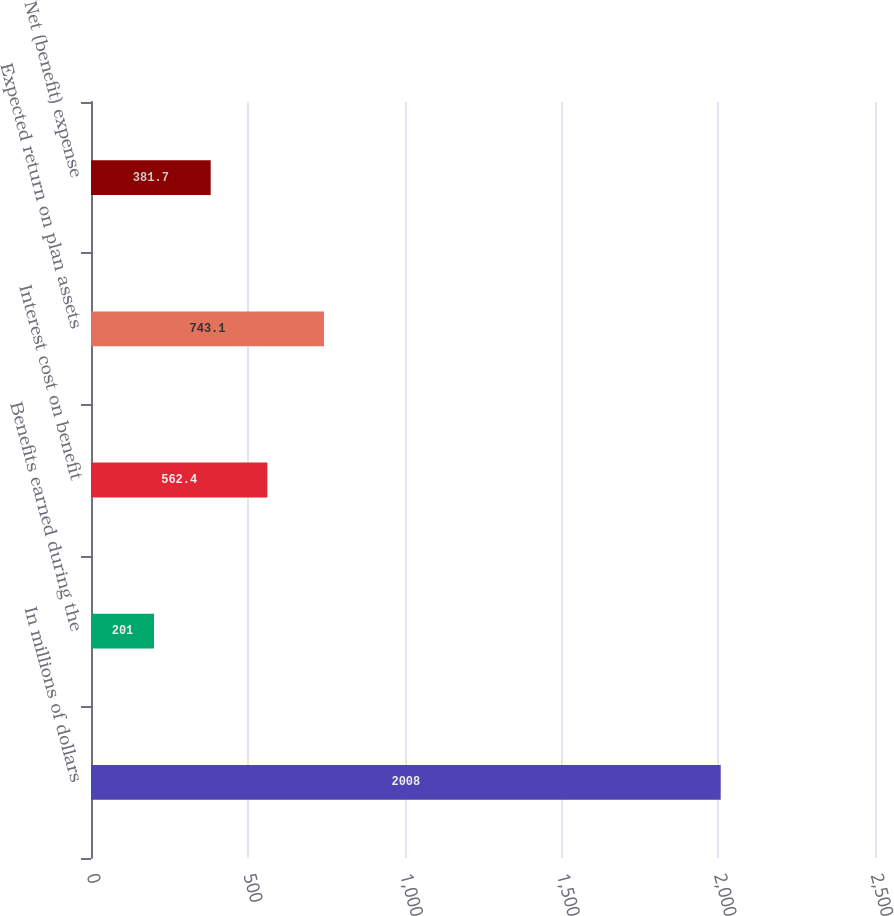<chart> <loc_0><loc_0><loc_500><loc_500><bar_chart><fcel>In millions of dollars<fcel>Benefits earned during the<fcel>Interest cost on benefit<fcel>Expected return on plan assets<fcel>Net (benefit) expense<nl><fcel>2008<fcel>201<fcel>562.4<fcel>743.1<fcel>381.7<nl></chart> 